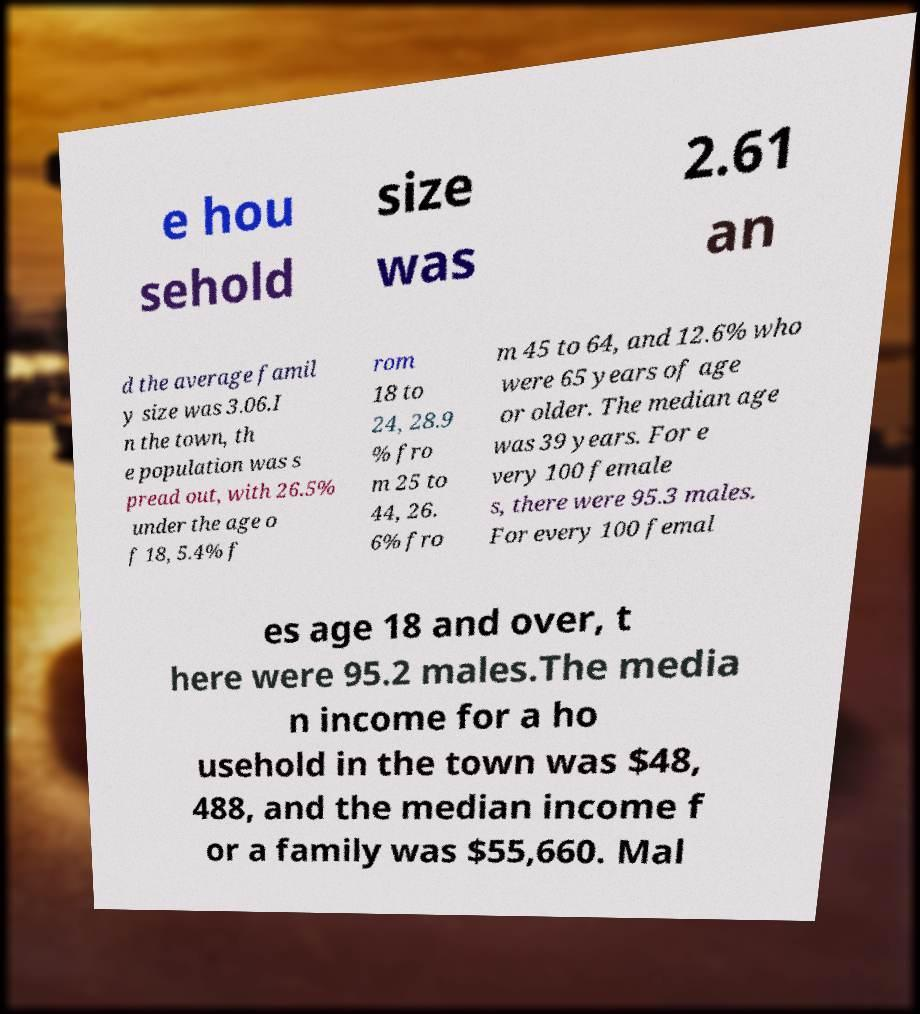What messages or text are displayed in this image? I need them in a readable, typed format. e hou sehold size was 2.61 an d the average famil y size was 3.06.I n the town, th e population was s pread out, with 26.5% under the age o f 18, 5.4% f rom 18 to 24, 28.9 % fro m 25 to 44, 26. 6% fro m 45 to 64, and 12.6% who were 65 years of age or older. The median age was 39 years. For e very 100 female s, there were 95.3 males. For every 100 femal es age 18 and over, t here were 95.2 males.The media n income for a ho usehold in the town was $48, 488, and the median income f or a family was $55,660. Mal 